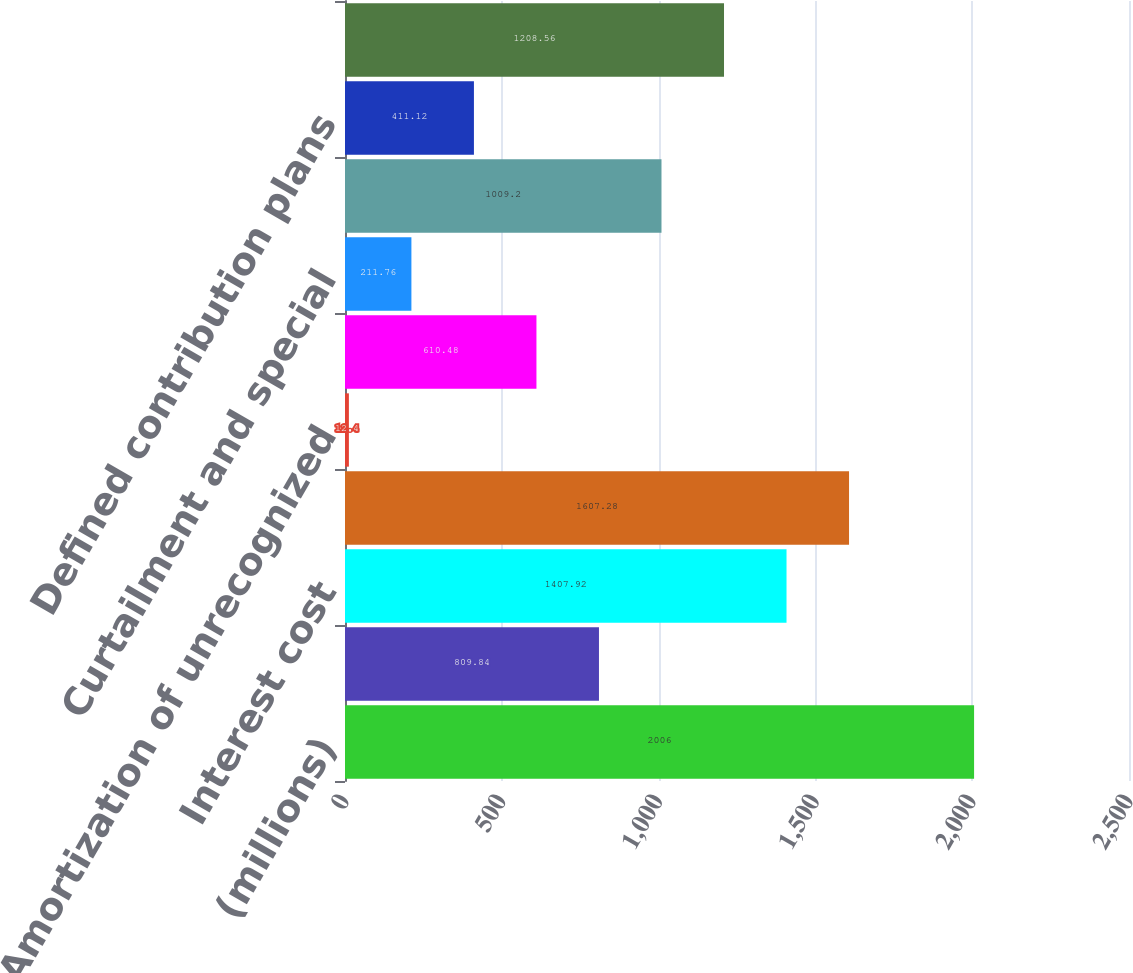<chart> <loc_0><loc_0><loc_500><loc_500><bar_chart><fcel>(millions)<fcel>Service cost<fcel>Interest cost<fcel>Expected return on plan assets<fcel>Amortization of unrecognized<fcel>Recognized net loss<fcel>Curtailment and special<fcel>Defined benefit plans<fcel>Defined contribution plans<fcel>Total<nl><fcel>2006<fcel>809.84<fcel>1407.92<fcel>1607.28<fcel>12.4<fcel>610.48<fcel>211.76<fcel>1009.2<fcel>411.12<fcel>1208.56<nl></chart> 